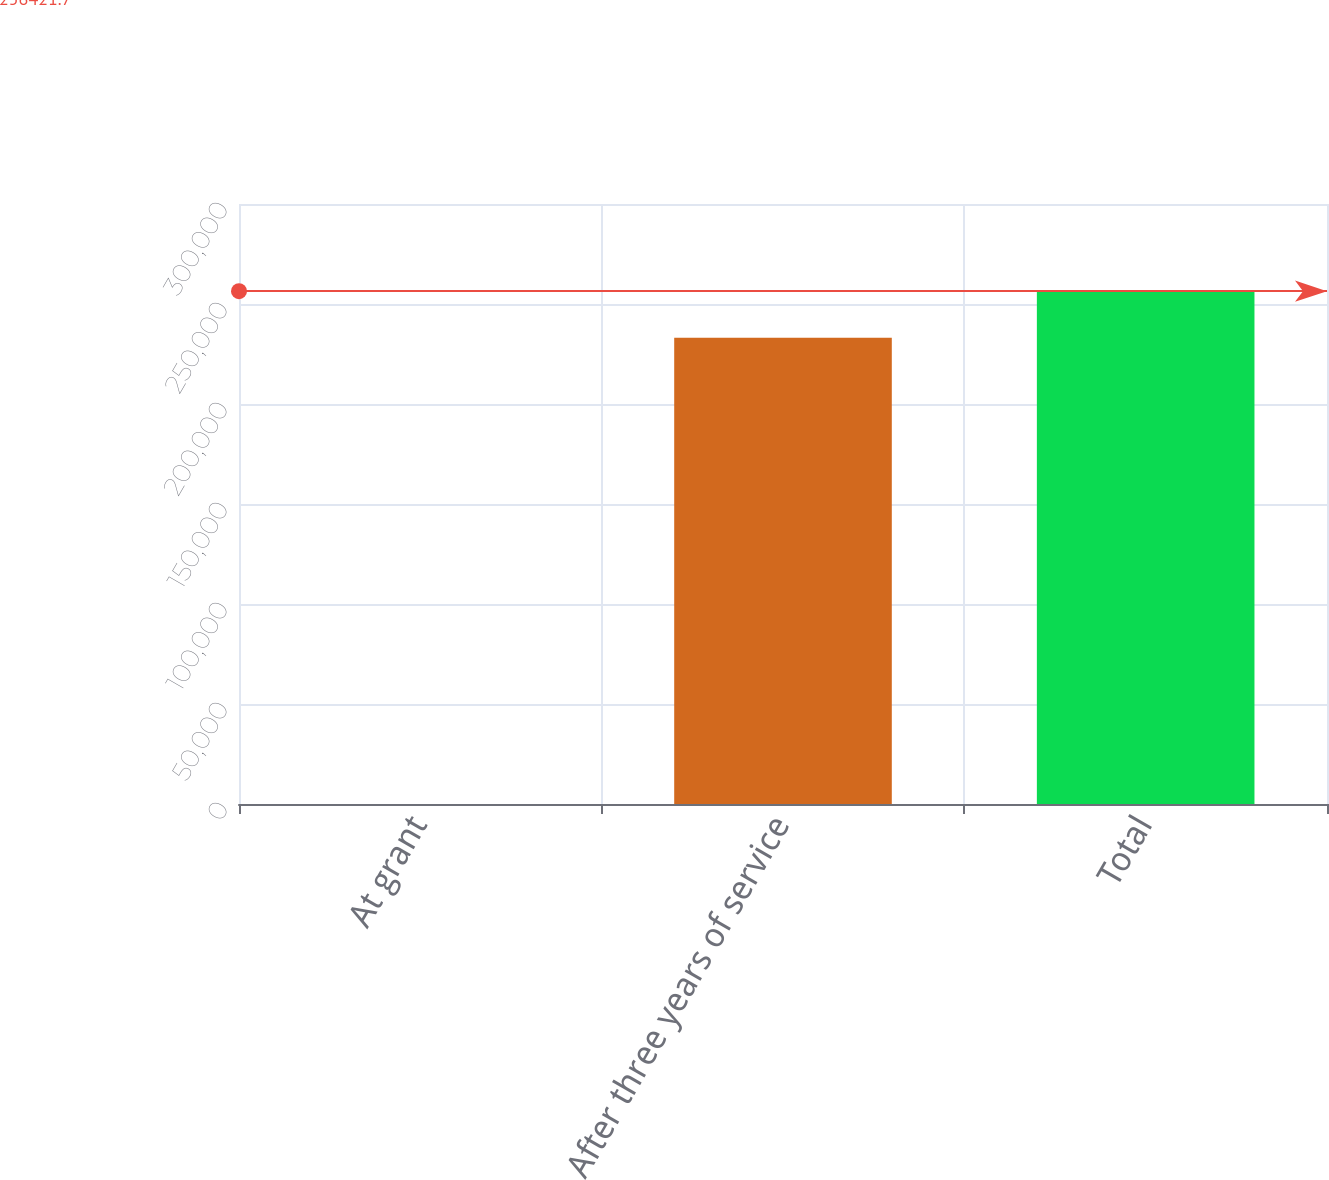Convert chart. <chart><loc_0><loc_0><loc_500><loc_500><bar_chart><fcel>At grant<fcel>After three years of service<fcel>Total<nl><fcel>4.04<fcel>233111<fcel>256422<nl></chart> 